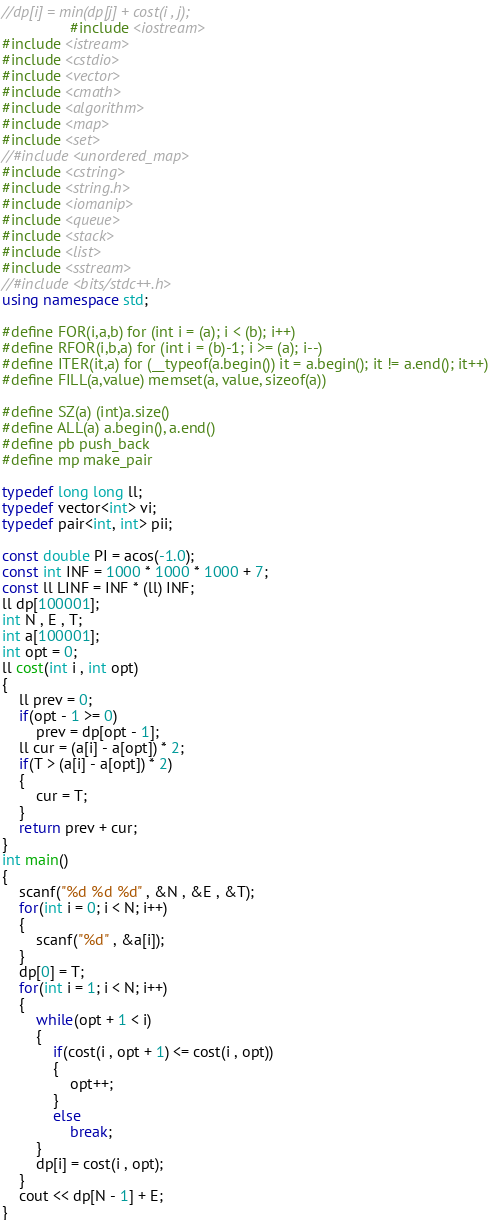Convert code to text. <code><loc_0><loc_0><loc_500><loc_500><_C++_>//dp[i] = min(dp[j] + cost(i , j);
                #include <iostream>
#include <istream>
#include <cstdio>
#include <vector>
#include <cmath>
#include <algorithm>
#include <map>
#include <set>
//#include <unordered_map>
#include <cstring>
#include <string.h>
#include <iomanip>
#include <queue>
#include <stack>
#include <list>
#include <sstream>
//#include <bits/stdc++.h>
using namespace std;

#define FOR(i,a,b) for (int i = (a); i < (b); i++)
#define RFOR(i,b,a) for (int i = (b)-1; i >= (a); i--)
#define ITER(it,a) for (__typeof(a.begin()) it = a.begin(); it != a.end(); it++)
#define FILL(a,value) memset(a, value, sizeof(a))

#define SZ(a) (int)a.size()
#define ALL(a) a.begin(), a.end()
#define pb push_back
#define mp make_pair

typedef long long ll;
typedef vector<int> vi;
typedef pair<int, int> pii;

const double PI = acos(-1.0);
const int INF = 1000 * 1000 * 1000 + 7;
const ll LINF = INF * (ll) INF;
ll dp[100001];
int N , E , T;
int a[100001];
int opt = 0;
ll cost(int i , int opt)
{
	ll prev = 0;
	if(opt - 1 >= 0)
		prev = dp[opt - 1];
	ll cur = (a[i] - a[opt]) * 2;
	if(T > (a[i] - a[opt]) * 2)
	{
		cur = T;
	}
	return prev + cur;
}
int main()
{
	scanf("%d %d %d" , &N , &E , &T);
	for(int i = 0; i < N; i++)
	{
		scanf("%d" , &a[i]);
	}
	dp[0] = T;
	for(int i = 1; i < N; i++)
	{
		while(opt + 1 < i)
		{
			if(cost(i , opt + 1) <= cost(i , opt))
			{
				opt++;
			}
			else
				break;
		}
		dp[i] = cost(i , opt);
	}
	cout << dp[N - 1] + E;
}


</code> 